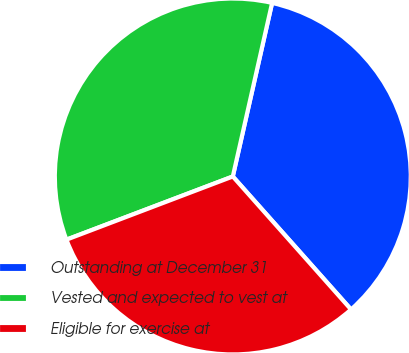Convert chart to OTSL. <chart><loc_0><loc_0><loc_500><loc_500><pie_chart><fcel>Outstanding at December 31<fcel>Vested and expected to vest at<fcel>Eligible for exercise at<nl><fcel>34.89%<fcel>34.32%<fcel>30.79%<nl></chart> 